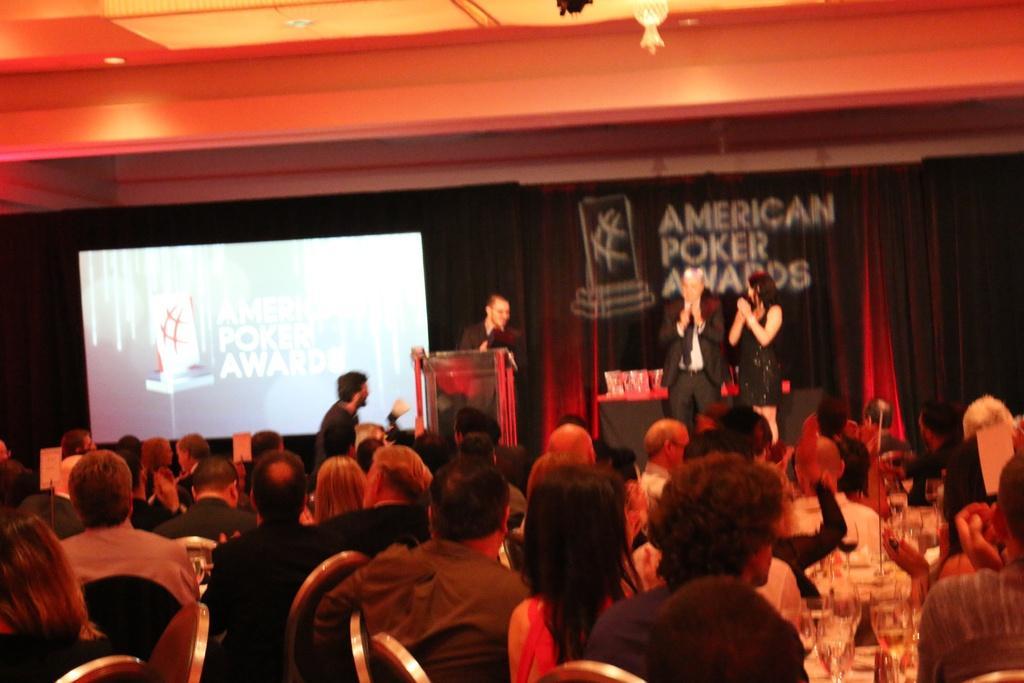How would you summarize this image in a sentence or two? In this picture we can see a group of people sitting on the chairs. In front of the people, there are four persons standing and there are curtains, a podium, projector screen and some objects. At the top of the image, there are ceiling lights and an object. In the bottom right corner of the image, there are glasses. 